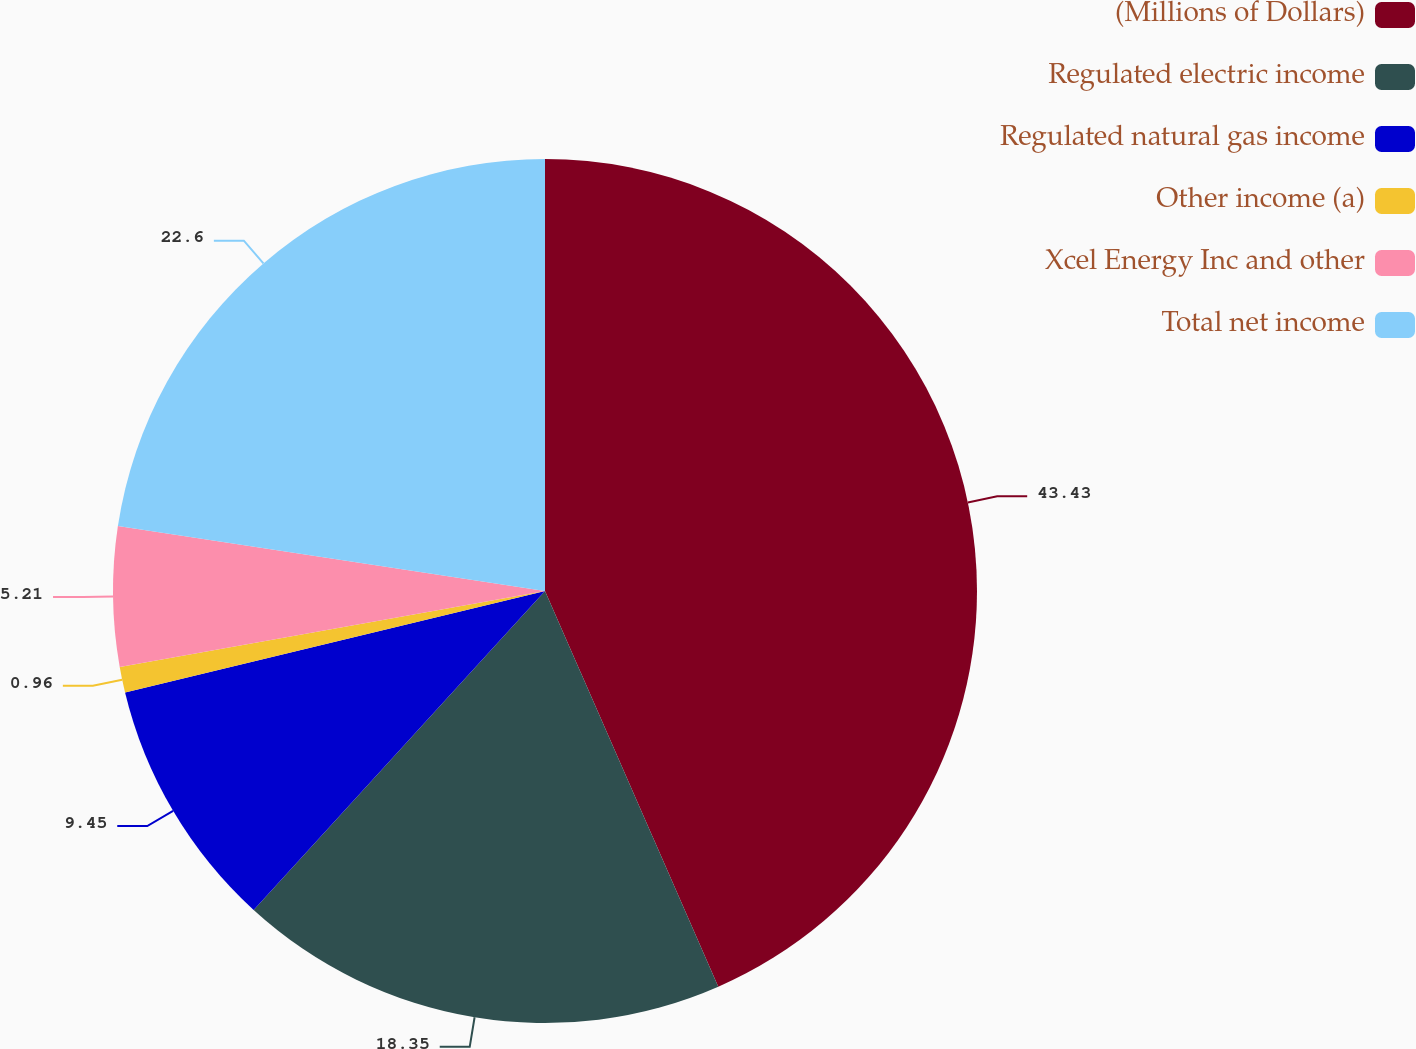Convert chart to OTSL. <chart><loc_0><loc_0><loc_500><loc_500><pie_chart><fcel>(Millions of Dollars)<fcel>Regulated electric income<fcel>Regulated natural gas income<fcel>Other income (a)<fcel>Xcel Energy Inc and other<fcel>Total net income<nl><fcel>43.43%<fcel>18.35%<fcel>9.45%<fcel>0.96%<fcel>5.21%<fcel>22.6%<nl></chart> 